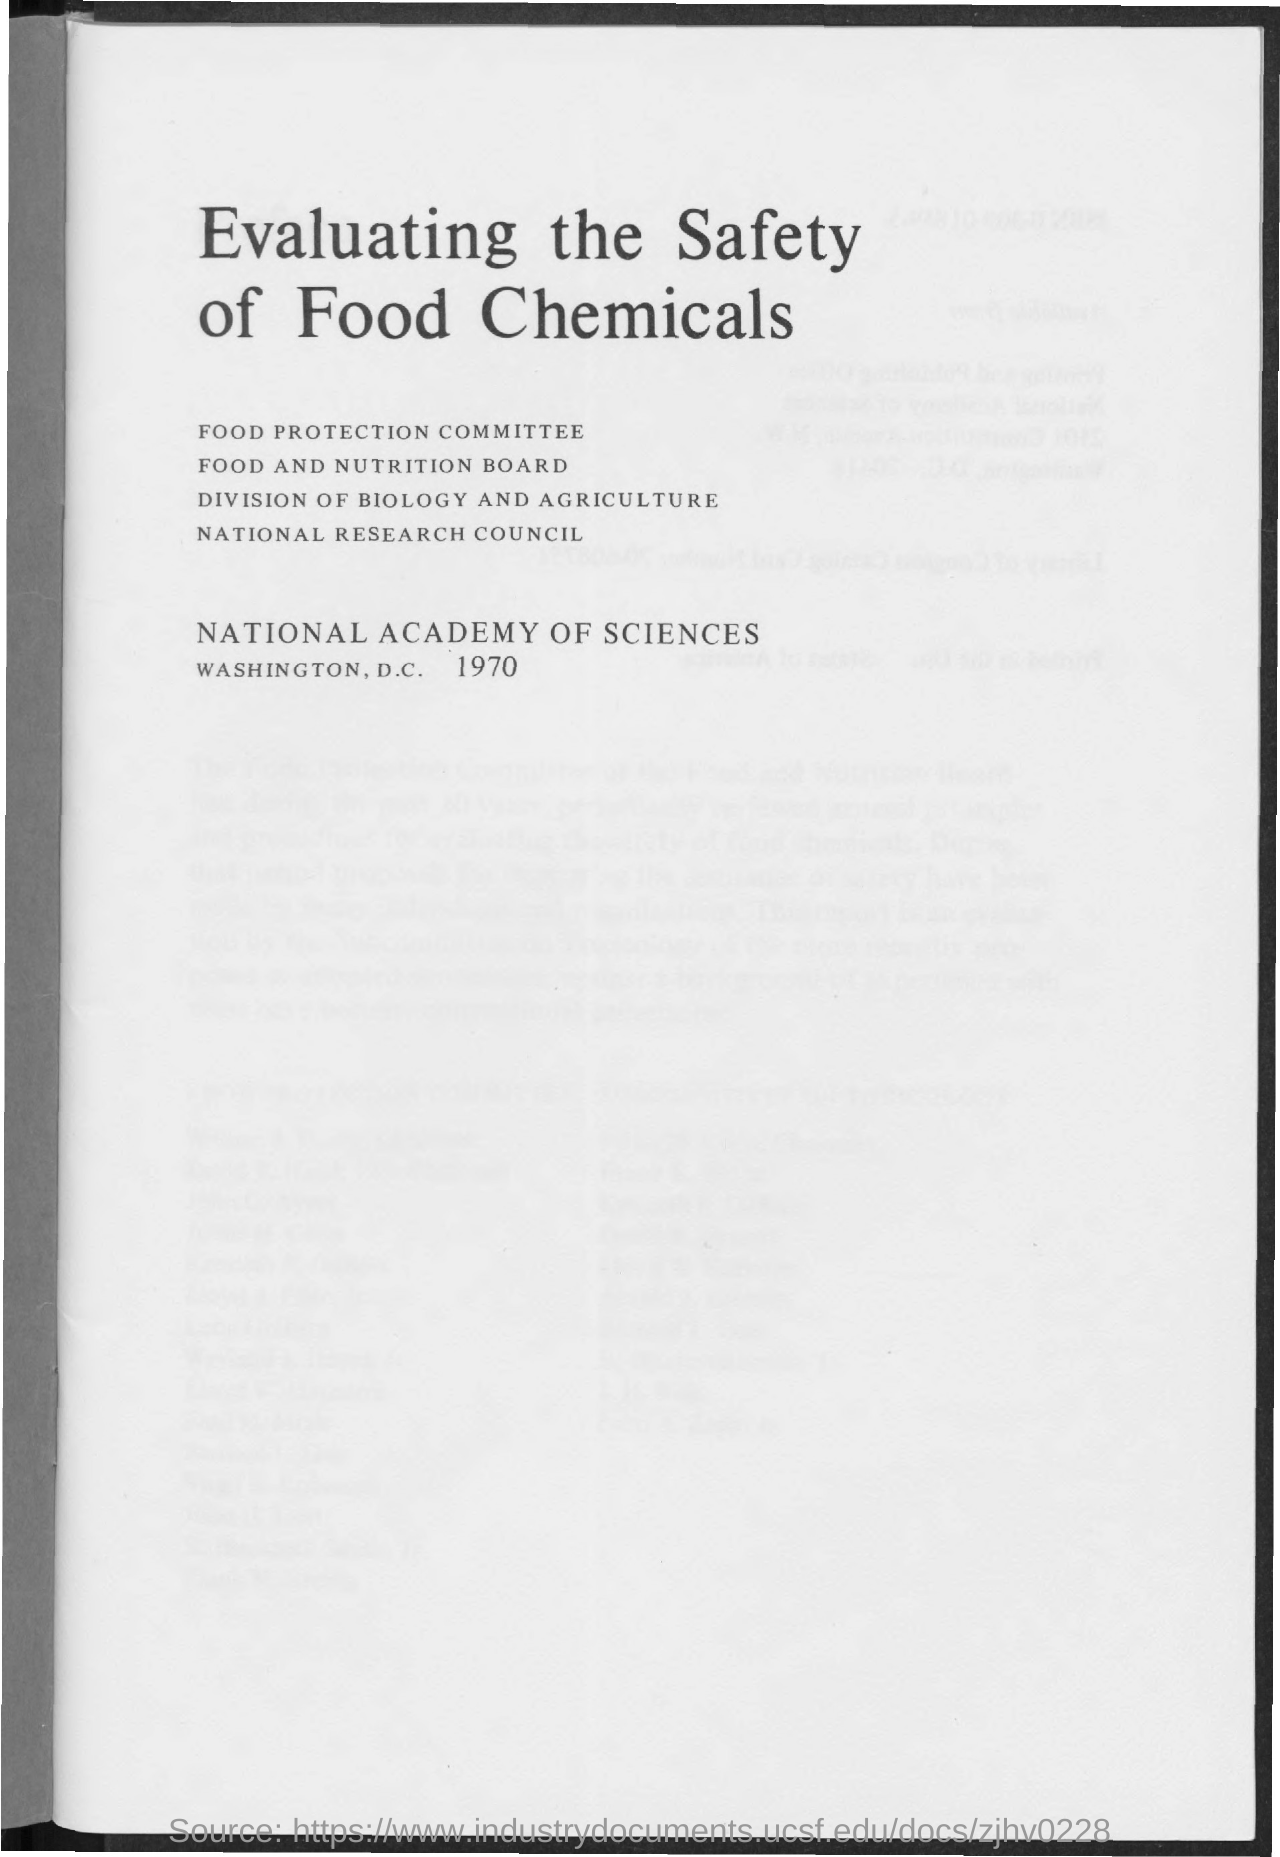What is the year mentioned in the document?
 1970 